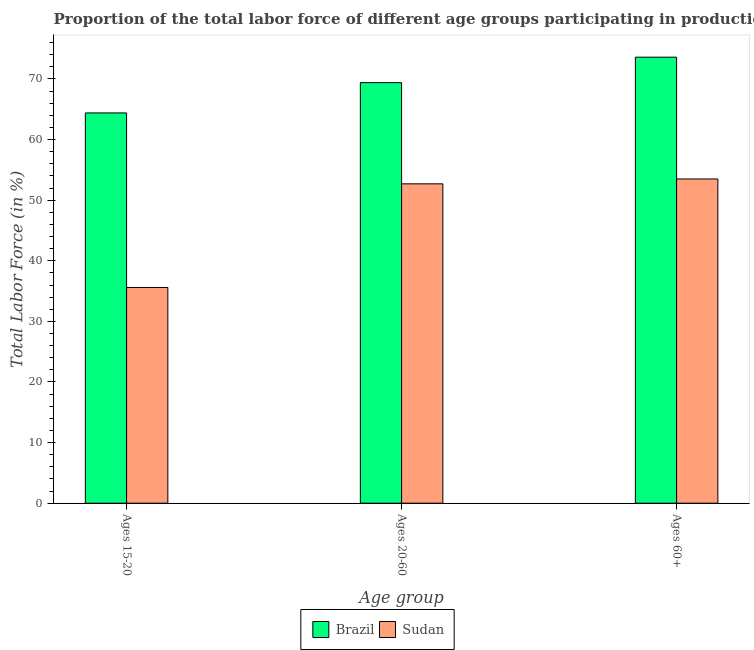How many different coloured bars are there?
Ensure brevity in your answer.  2. Are the number of bars per tick equal to the number of legend labels?
Offer a very short reply. Yes. Are the number of bars on each tick of the X-axis equal?
Your answer should be compact. Yes. How many bars are there on the 3rd tick from the left?
Give a very brief answer. 2. What is the label of the 2nd group of bars from the left?
Ensure brevity in your answer.  Ages 20-60. What is the percentage of labor force within the age group 20-60 in Brazil?
Keep it short and to the point. 69.4. Across all countries, what is the maximum percentage of labor force within the age group 15-20?
Your answer should be very brief. 64.4. Across all countries, what is the minimum percentage of labor force above age 60?
Ensure brevity in your answer.  53.5. In which country was the percentage of labor force within the age group 20-60 minimum?
Make the answer very short. Sudan. What is the total percentage of labor force within the age group 15-20 in the graph?
Offer a terse response. 100. What is the difference between the percentage of labor force within the age group 15-20 in Brazil and that in Sudan?
Make the answer very short. 28.8. What is the difference between the percentage of labor force within the age group 20-60 in Sudan and the percentage of labor force above age 60 in Brazil?
Keep it short and to the point. -20.9. What is the average percentage of labor force above age 60 per country?
Keep it short and to the point. 63.55. In how many countries, is the percentage of labor force above age 60 greater than 6 %?
Offer a terse response. 2. What is the ratio of the percentage of labor force within the age group 20-60 in Sudan to that in Brazil?
Offer a very short reply. 0.76. Is the percentage of labor force within the age group 15-20 in Brazil less than that in Sudan?
Your response must be concise. No. Is the difference between the percentage of labor force within the age group 20-60 in Brazil and Sudan greater than the difference between the percentage of labor force within the age group 15-20 in Brazil and Sudan?
Your response must be concise. No. What is the difference between the highest and the second highest percentage of labor force above age 60?
Provide a succinct answer. 20.1. What is the difference between the highest and the lowest percentage of labor force within the age group 20-60?
Your response must be concise. 16.7. In how many countries, is the percentage of labor force above age 60 greater than the average percentage of labor force above age 60 taken over all countries?
Offer a very short reply. 1. Is it the case that in every country, the sum of the percentage of labor force within the age group 15-20 and percentage of labor force within the age group 20-60 is greater than the percentage of labor force above age 60?
Make the answer very short. Yes. How many bars are there?
Your answer should be compact. 6. How many countries are there in the graph?
Offer a very short reply. 2. What is the difference between two consecutive major ticks on the Y-axis?
Your answer should be very brief. 10. How many legend labels are there?
Ensure brevity in your answer.  2. How are the legend labels stacked?
Your answer should be compact. Horizontal. What is the title of the graph?
Your answer should be very brief. Proportion of the total labor force of different age groups participating in production in 2004. What is the label or title of the X-axis?
Provide a succinct answer. Age group. What is the Total Labor Force (in %) of Brazil in Ages 15-20?
Your response must be concise. 64.4. What is the Total Labor Force (in %) in Sudan in Ages 15-20?
Your answer should be compact. 35.6. What is the Total Labor Force (in %) of Brazil in Ages 20-60?
Keep it short and to the point. 69.4. What is the Total Labor Force (in %) of Sudan in Ages 20-60?
Offer a terse response. 52.7. What is the Total Labor Force (in %) of Brazil in Ages 60+?
Give a very brief answer. 73.6. What is the Total Labor Force (in %) in Sudan in Ages 60+?
Your response must be concise. 53.5. Across all Age group, what is the maximum Total Labor Force (in %) in Brazil?
Provide a short and direct response. 73.6. Across all Age group, what is the maximum Total Labor Force (in %) in Sudan?
Give a very brief answer. 53.5. Across all Age group, what is the minimum Total Labor Force (in %) of Brazil?
Give a very brief answer. 64.4. Across all Age group, what is the minimum Total Labor Force (in %) in Sudan?
Make the answer very short. 35.6. What is the total Total Labor Force (in %) in Brazil in the graph?
Your response must be concise. 207.4. What is the total Total Labor Force (in %) of Sudan in the graph?
Offer a very short reply. 141.8. What is the difference between the Total Labor Force (in %) in Brazil in Ages 15-20 and that in Ages 20-60?
Keep it short and to the point. -5. What is the difference between the Total Labor Force (in %) in Sudan in Ages 15-20 and that in Ages 20-60?
Make the answer very short. -17.1. What is the difference between the Total Labor Force (in %) of Sudan in Ages 15-20 and that in Ages 60+?
Ensure brevity in your answer.  -17.9. What is the difference between the Total Labor Force (in %) in Brazil in Ages 20-60 and that in Ages 60+?
Your answer should be very brief. -4.2. What is the difference between the Total Labor Force (in %) in Brazil in Ages 15-20 and the Total Labor Force (in %) in Sudan in Ages 60+?
Your response must be concise. 10.9. What is the difference between the Total Labor Force (in %) in Brazil in Ages 20-60 and the Total Labor Force (in %) in Sudan in Ages 60+?
Make the answer very short. 15.9. What is the average Total Labor Force (in %) of Brazil per Age group?
Offer a terse response. 69.13. What is the average Total Labor Force (in %) of Sudan per Age group?
Offer a very short reply. 47.27. What is the difference between the Total Labor Force (in %) in Brazil and Total Labor Force (in %) in Sudan in Ages 15-20?
Provide a short and direct response. 28.8. What is the difference between the Total Labor Force (in %) of Brazil and Total Labor Force (in %) of Sudan in Ages 20-60?
Give a very brief answer. 16.7. What is the difference between the Total Labor Force (in %) in Brazil and Total Labor Force (in %) in Sudan in Ages 60+?
Your answer should be very brief. 20.1. What is the ratio of the Total Labor Force (in %) in Brazil in Ages 15-20 to that in Ages 20-60?
Provide a short and direct response. 0.93. What is the ratio of the Total Labor Force (in %) in Sudan in Ages 15-20 to that in Ages 20-60?
Your answer should be compact. 0.68. What is the ratio of the Total Labor Force (in %) in Brazil in Ages 15-20 to that in Ages 60+?
Keep it short and to the point. 0.88. What is the ratio of the Total Labor Force (in %) of Sudan in Ages 15-20 to that in Ages 60+?
Keep it short and to the point. 0.67. What is the ratio of the Total Labor Force (in %) of Brazil in Ages 20-60 to that in Ages 60+?
Provide a succinct answer. 0.94. 